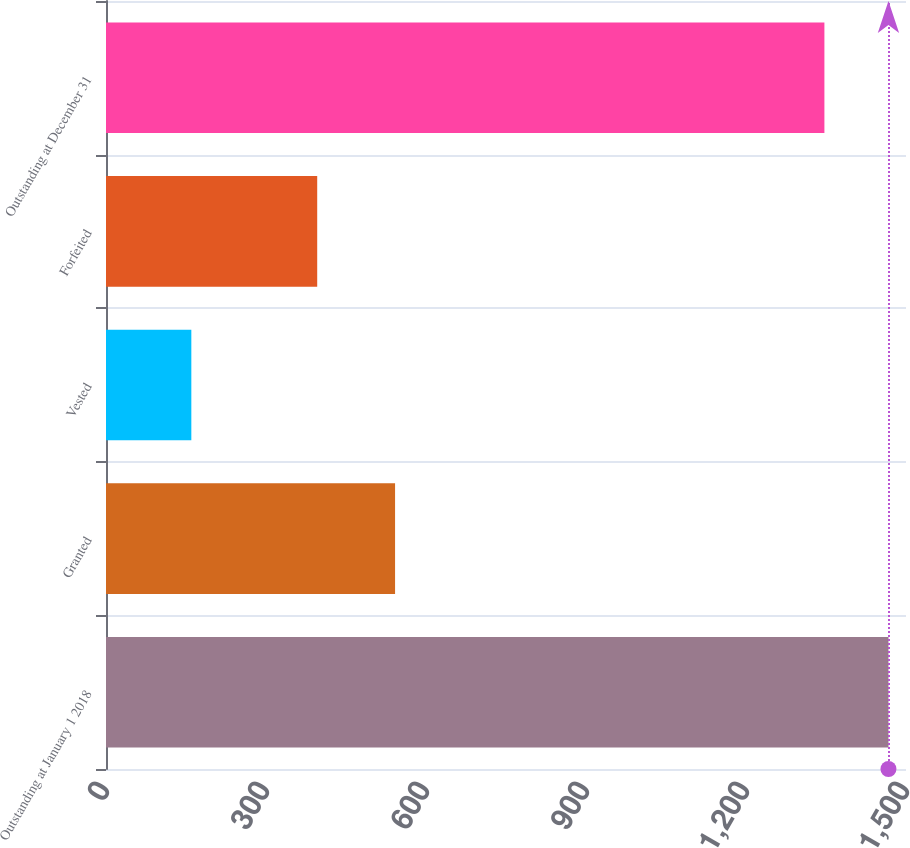Convert chart to OTSL. <chart><loc_0><loc_0><loc_500><loc_500><bar_chart><fcel>Outstanding at January 1 2018<fcel>Granted<fcel>Vested<fcel>Forfeited<fcel>Outstanding at December 31<nl><fcel>1467.1<fcel>542<fcel>160<fcel>396<fcel>1347<nl></chart> 